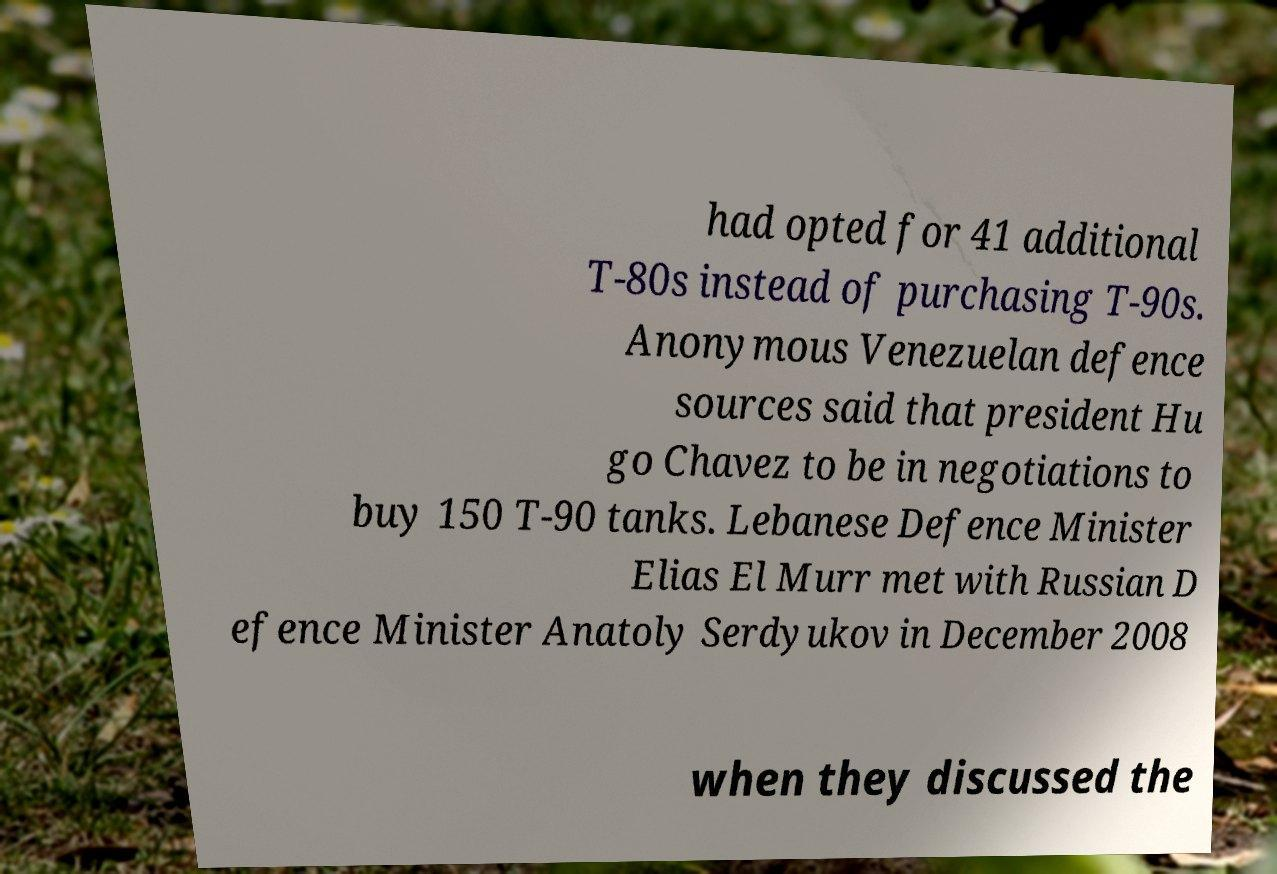Can you read and provide the text displayed in the image?This photo seems to have some interesting text. Can you extract and type it out for me? had opted for 41 additional T-80s instead of purchasing T-90s. Anonymous Venezuelan defence sources said that president Hu go Chavez to be in negotiations to buy 150 T-90 tanks. Lebanese Defence Minister Elias El Murr met with Russian D efence Minister Anatoly Serdyukov in December 2008 when they discussed the 